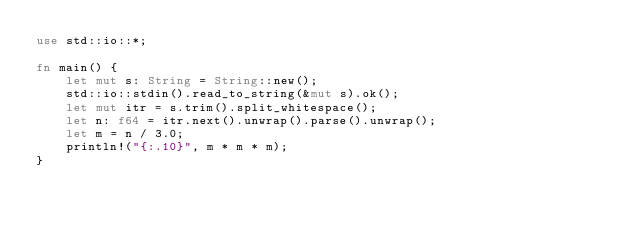Convert code to text. <code><loc_0><loc_0><loc_500><loc_500><_Rust_>use std::io::*;

fn main() {
    let mut s: String = String::new();
    std::io::stdin().read_to_string(&mut s).ok();
    let mut itr = s.trim().split_whitespace();
    let n: f64 = itr.next().unwrap().parse().unwrap();
    let m = n / 3.0;
    println!("{:.10}", m * m * m);
}
</code> 